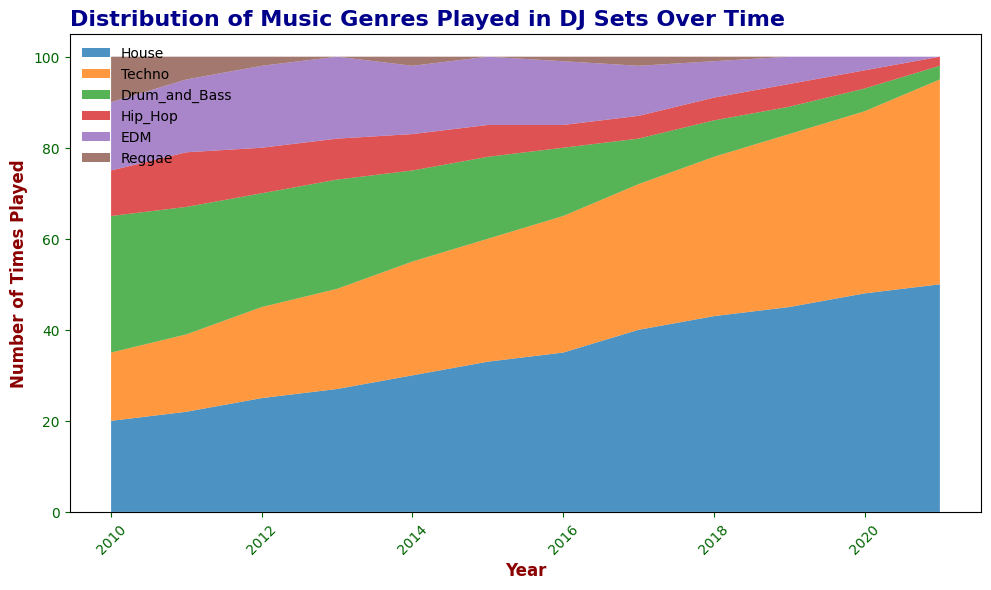Which genre had the highest increase in the number of times played from 2010 to 2021? To find the genre with the highest increase, you look at the starting value for each genre in 2010 and compare it to its value in 2021. Calculate the difference for each genre and identify the maximum.
Answer: House Which year saw the peak number of Drum_and_Bass tracks played? By observing the height of the Drum_and_Bass area across different years, you can see that it reaches its maximum height in the year before it starts to diminish.
Answer: 2010 How much more often was House played compared to Hip_Hop in 2018? Locate the values for House and Hip_Hop in 2018 and subtract the number of times Hip_Hop was played from the number of times House was played.
Answer: 38 Between 2010 and 2021, in which range of years did EDM see the most consistent number of plays? By looking at the width and evenness of the EDM area over time, you can see that it stays relatively consistent in height without significant drops or spikes.
Answer: 2014-2017 If you sum the number of Techno and Reggae tracks played in 2014, what do you get? Find the values for Techno and Reggae in 2014 and add them together: 25 (Techno) + 2 (Reggae) = 27.
Answer: 27 By how much did the number of Hip_Hop tracks played decrease from 2010 to 2020? Subtract the value of Hip_Hop tracks played in 2020 from the value in 2010: 10 - 4 = 6.
Answer: 6 Which genre(s) completely disappeared from your sets by 2021? Identify which areas in the stacked area chart reduce to zero by 2021.
Answer: Hip_Hop, EDM, Reggae In what year did House surpass Techno in terms of the number of times played? Find the year where the area representing House becomes taller than the area representing Techno for the first time.
Answer: 2017 How many total genres were played in 2013? Count the genres that have a non-zero value in the area chart for the year 2013.
Answer: 6 Which genre saw the most significant decline from its peak to 2021? Identify the genre with the highest peak value and compare it to the value in 2021 to find the maximum difference.
Answer: Drum_and_Bass 